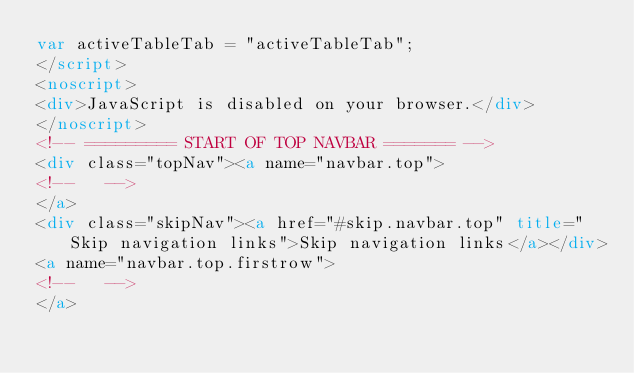Convert code to text. <code><loc_0><loc_0><loc_500><loc_500><_HTML_>var activeTableTab = "activeTableTab";
</script>
<noscript>
<div>JavaScript is disabled on your browser.</div>
</noscript>
<!-- ========= START OF TOP NAVBAR ======= -->
<div class="topNav"><a name="navbar.top">
<!--   -->
</a>
<div class="skipNav"><a href="#skip.navbar.top" title="Skip navigation links">Skip navigation links</a></div>
<a name="navbar.top.firstrow">
<!--   -->
</a></code> 